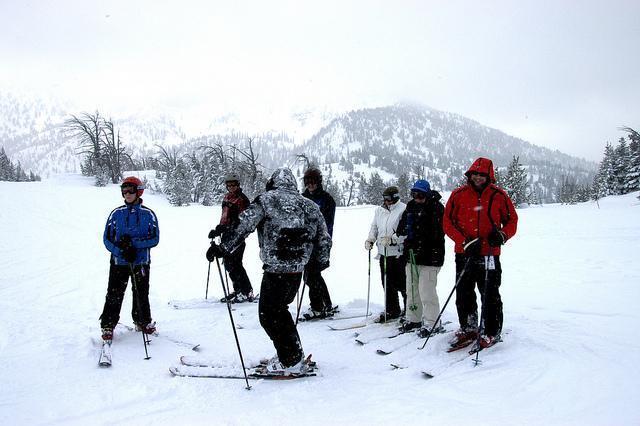How many people are there?
Give a very brief answer. 7. How many toilets are on the sidewalk?
Give a very brief answer. 0. 